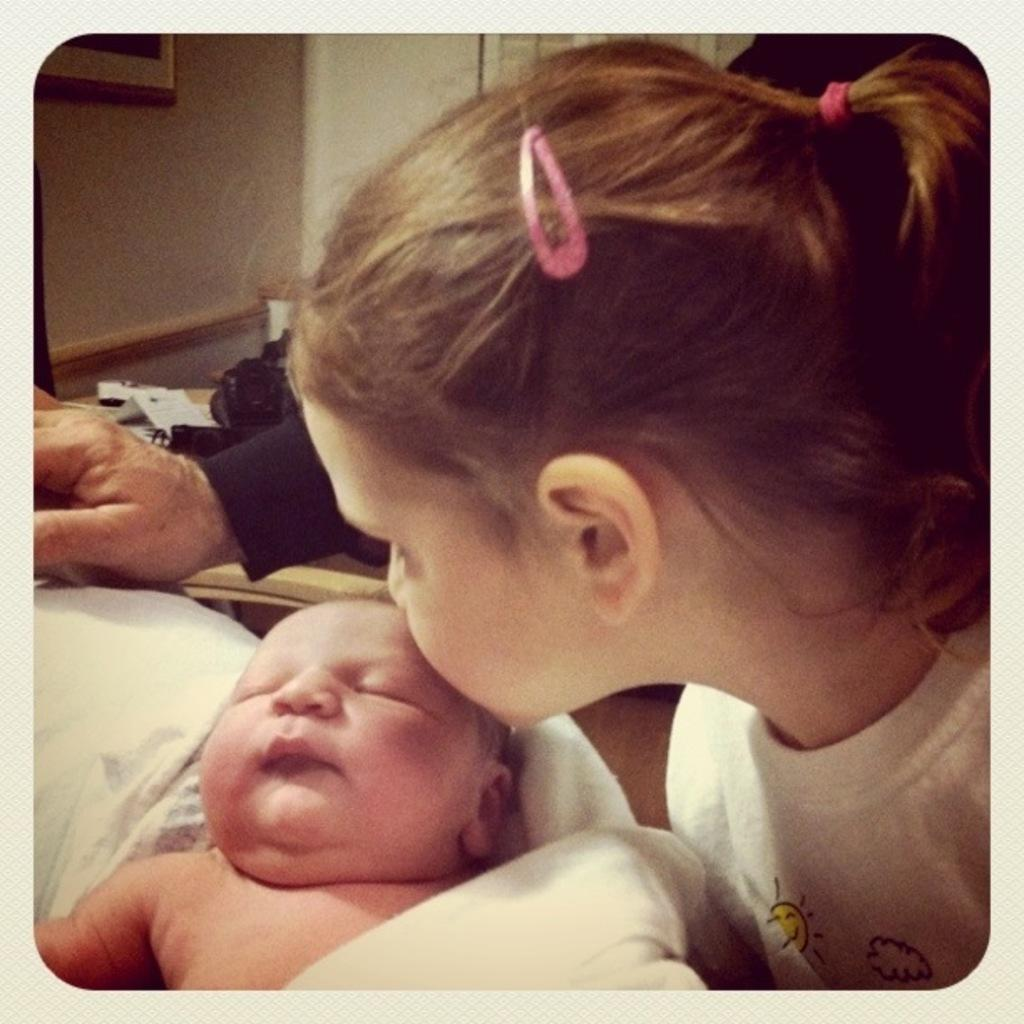Where is the kid located in the image? The kid is in the right corner of the image. What is the kid doing in the image? The kid is kissing a baby. How is the baby positioned in relation to the kid? The baby is in front of the kid. Is there anyone else present in the image? Yes, there is a person standing beside the kid and the baby. What type of card can be seen in the baby's nest in the image? There is no card or nest present in the image; it features a kid kissing a baby with a person standing beside them. 